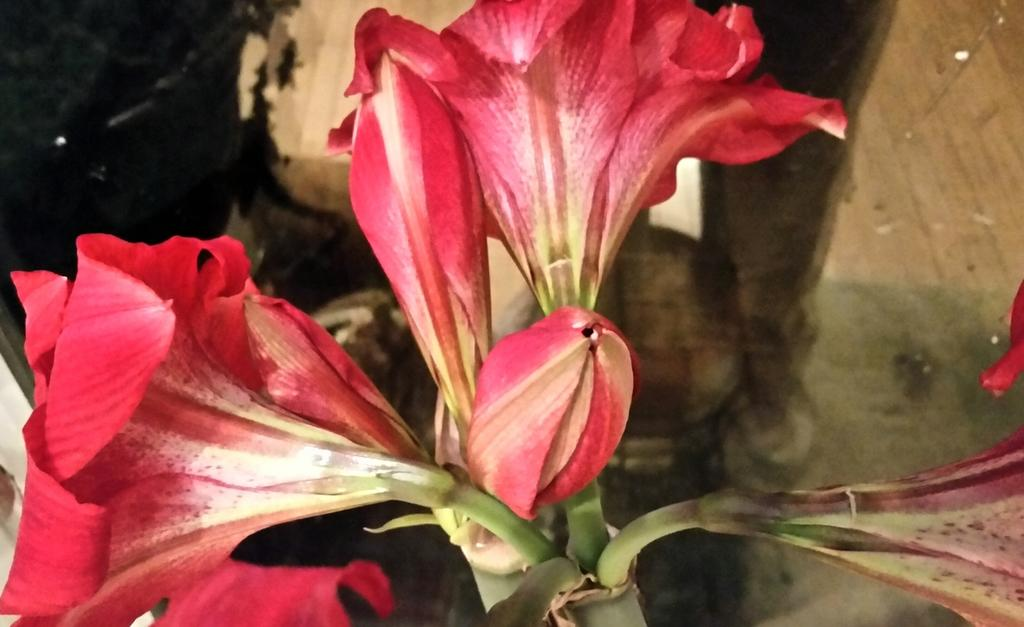What type of plants can be seen in the image? There are flowers in the image. How many icicles can be seen hanging from the flowers in the image? There are no icicles present in the image, as it features flowers. 